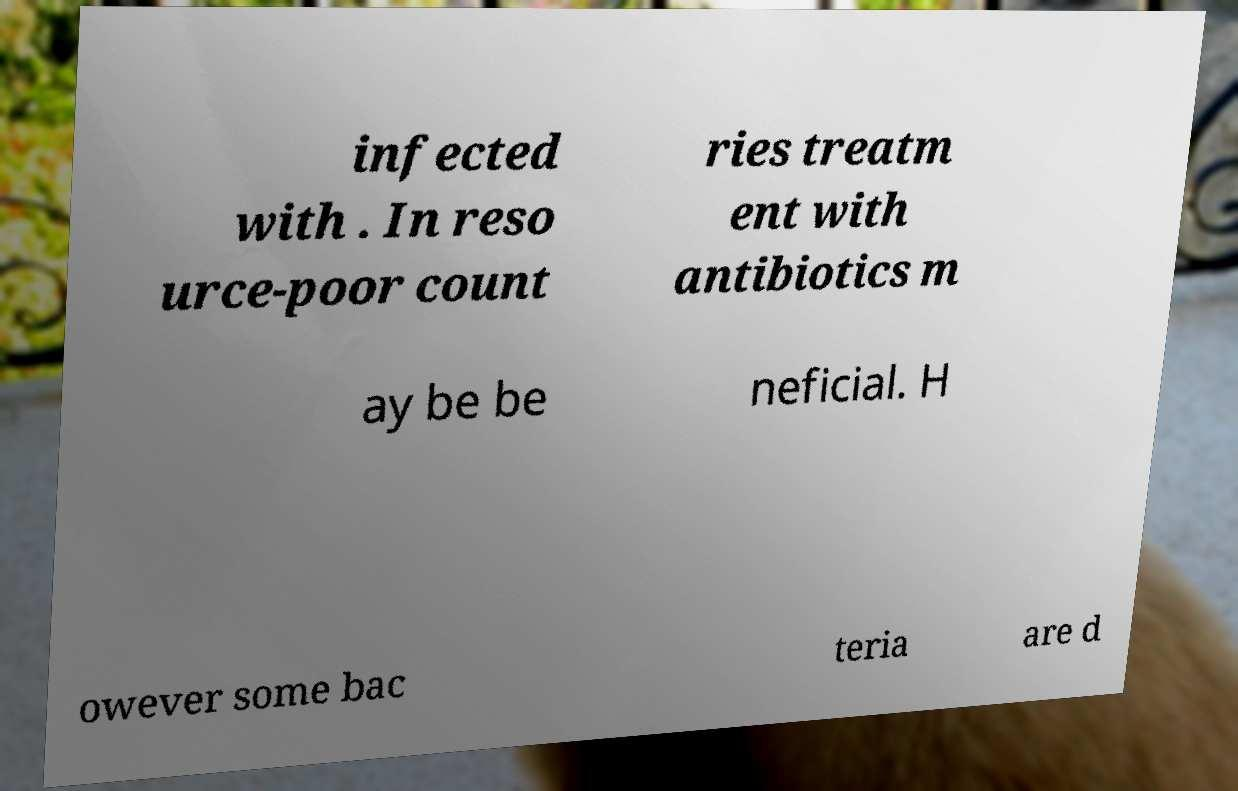Please read and relay the text visible in this image. What does it say? infected with . In reso urce-poor count ries treatm ent with antibiotics m ay be be neficial. H owever some bac teria are d 